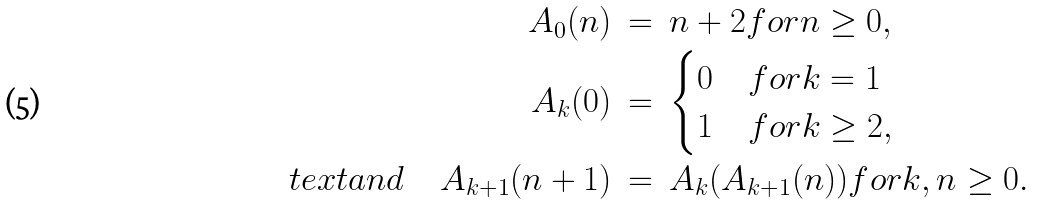<formula> <loc_0><loc_0><loc_500><loc_500>A _ { 0 } ( n ) & \ = \ n + 2 f o r n \geq 0 , \\ A _ { k } ( 0 ) & \ = \ \begin{cases} 0 & f o r k = 1 \\ 1 & f o r k \geq 2 , \end{cases} \\ \quad t e x t { a n d } \quad A _ { k + 1 } ( n + 1 ) & \ = \ A _ { k } ( { A _ { k + 1 } } ( n ) ) f o r k , n \geq 0 .</formula> 